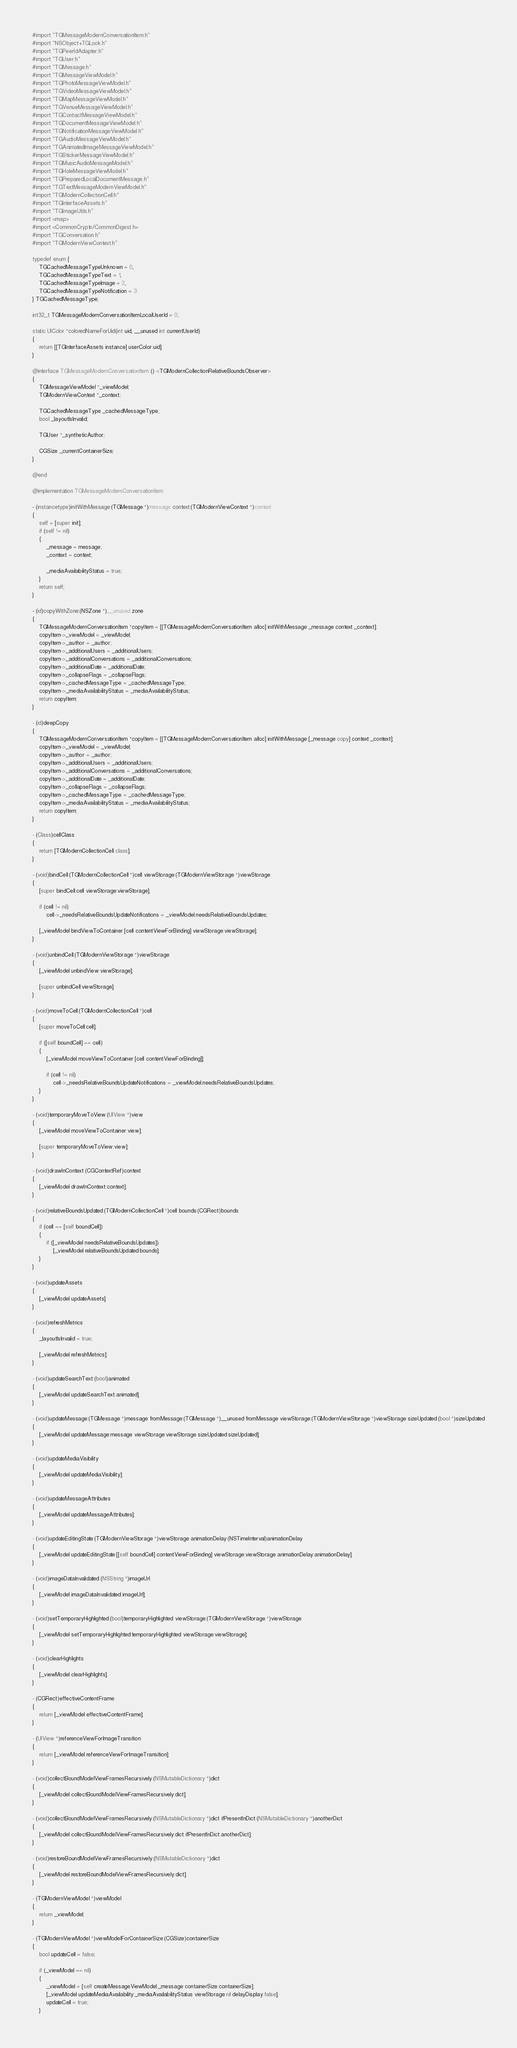Convert code to text. <code><loc_0><loc_0><loc_500><loc_500><_ObjectiveC_>#import "TGMessageModernConversationItem.h"
#import "NSObject+TGLock.h"
#import "TGPeerIdAdapter.h"
#import "TGUser.h"
#import "TGMessage.h"
#import "TGMessageViewModel.h"
#import "TGPhotoMessageViewModel.h"
#import "TGVideoMessageViewModel.h"
#import "TGMapMessageViewModel.h"
#import "TGVenueMessageViewModel.h"
#import "TGContactMessageViewModel.h"
#import "TGDocumentMessageViewModel.h"
#import "TGNotificationMessageViewModel.h"
#import "TGAudioMessageViewModel.h"
#import "TGAnimatedImageMessageViewModel.h"
#import "TGStickerMessageViewModel.h"
#import "TGMusicAudioMessageModel.h"
#import "TGHoleMessageViewModel.h"
#import "TGPreparedLocalDocumentMessage.h"
#import "TGTextMessageModernViewModel.h"
#import "TGModernCollectionCell.h"
#import "TGInterfaceAssets.h"
#import "TGImageUtils.h"
#import <map>
#import <CommonCrypto/CommonDigest.h>
#import "TGConversation.h"
#import "TGModernViewContext.h"

typedef enum {
    TGCachedMessageTypeUnknown = 0,
    TGCachedMessageTypeText = 1,
    TGCachedMessageTypeImage = 2,
    TGCachedMessageTypeNotification = 3
} TGCachedMessageType;

int32_t TGMessageModernConversationItemLocalUserId = 0;

static UIColor *coloredNameForUid(int uid, __unused int currentUserId)
{
    return [[TGInterfaceAssets instance] userColor:uid];
}

@interface TGMessageModernConversationItem () <TGModernCollectionRelativeBoundsObserver>
{
    TGMessageViewModel *_viewModel;
    TGModernViewContext *_context;
    
    TGCachedMessageType _cachedMessageType;
    bool _layoutIsInvalid;
    
    TGUser *_syntheticAuthor;
    
    CGSize _currentContainerSize;
}

@end

@implementation TGMessageModernConversationItem

- (instancetype)initWithMessage:(TGMessage *)message context:(TGModernViewContext *)context
{
    self = [super init];
    if (self != nil)
    {
        _message = message;
        _context = context;
        
        _mediaAvailabilityStatus = true;
    }
    return self;
}

- (id)copyWithZone:(NSZone *)__unused zone
{
    TGMessageModernConversationItem *copyItem = [[TGMessageModernConversationItem alloc] initWithMessage:_message context:_context];
    copyItem->_viewModel = _viewModel;
    copyItem->_author = _author;
    copyItem->_additionalUsers = _additionalUsers;
    copyItem->_additionalConversations = _additionalConversations;
    copyItem->_additionalDate = _additionalDate;
    copyItem->_collapseFlags = _collapseFlags;
    copyItem->_cachedMessageType = _cachedMessageType;
    copyItem->_mediaAvailabilityStatus = _mediaAvailabilityStatus;
    return copyItem;
}

- (id)deepCopy
{
    TGMessageModernConversationItem *copyItem = [[TGMessageModernConversationItem alloc] initWithMessage:[_message copy] context:_context];
    copyItem->_viewModel = _viewModel;
    copyItem->_author = _author;
    copyItem->_additionalUsers = _additionalUsers;
    copyItem->_additionalConversations = _additionalConversations;
    copyItem->_additionalDate = _additionalDate;
    copyItem->_collapseFlags = _collapseFlags;
    copyItem->_cachedMessageType = _cachedMessageType;
    copyItem->_mediaAvailabilityStatus = _mediaAvailabilityStatus;
    return copyItem;
}

- (Class)cellClass
{
    return [TGModernCollectionCell class];
}

- (void)bindCell:(TGModernCollectionCell *)cell viewStorage:(TGModernViewStorage *)viewStorage
{
    [super bindCell:cell viewStorage:viewStorage];
    
    if (cell != nil)
        cell->_needsRelativeBoundsUpdateNotifications = _viewModel.needsRelativeBoundsUpdates;
    
    [_viewModel bindViewToContainer:[cell contentViewForBinding] viewStorage:viewStorage];
}

- (void)unbindCell:(TGModernViewStorage *)viewStorage
{
    [_viewModel unbindView:viewStorage];
    
    [super unbindCell:viewStorage];
}

- (void)moveToCell:(TGModernCollectionCell *)cell
{
    [super moveToCell:cell];
    
    if ([self boundCell] == cell)
    {
        [_viewModel moveViewToContainer:[cell contentViewForBinding]];
        
        if (cell != nil)
            cell->_needsRelativeBoundsUpdateNotifications = _viewModel.needsRelativeBoundsUpdates;
    }
}

- (void)temporaryMoveToView:(UIView *)view
{
    [_viewModel moveViewToContainer:view];
    
    [super temporaryMoveToView:view];
}

- (void)drawInContext:(CGContextRef)context
{
    [_viewModel drawInContext:context];
}

- (void)relativeBoundsUpdated:(TGModernCollectionCell *)cell bounds:(CGRect)bounds
{
    if (cell == [self boundCell])
    {
        if ([_viewModel needsRelativeBoundsUpdates])
            [_viewModel relativeBoundsUpdated:bounds];
    }
}

- (void)updateAssets
{
    [_viewModel updateAssets];
}

- (void)refreshMetrics
{
    _layoutIsInvalid = true;
    
    [_viewModel refreshMetrics];
}

- (void)updateSearchText:(bool)animated
{
    [_viewModel updateSearchText:animated];
}

- (void)updateMessage:(TGMessage *)message fromMessage:(TGMessage *)__unused fromMessage viewStorage:(TGModernViewStorage *)viewStorage sizeUpdated:(bool *)sizeUpdated
{
    [_viewModel updateMessage:message viewStorage:viewStorage sizeUpdated:sizeUpdated];
}

- (void)updateMediaVisibility
{
    [_viewModel updateMediaVisibility];
}

- (void)updateMessageAttributes
{
    [_viewModel updateMessageAttributes];
}

- (void)updateEditingState:(TGModernViewStorage *)viewStorage animationDelay:(NSTimeInterval)animationDelay
{
    [_viewModel updateEditingState:[[self boundCell] contentViewForBinding] viewStorage:viewStorage animationDelay:animationDelay];
}

- (void)imageDataInvalidated:(NSString *)imageUrl
{
    [_viewModel imageDataInvalidated:imageUrl];
}

- (void)setTemporaryHighlighted:(bool)temporaryHighlighted viewStorage:(TGModernViewStorage *)viewStorage
{
    [_viewModel setTemporaryHighlighted:temporaryHighlighted viewStorage:viewStorage];
}

- (void)clearHighlights
{
    [_viewModel clearHighlights];
}

- (CGRect)effectiveContentFrame
{
    return [_viewModel effectiveContentFrame];
}

- (UIView *)referenceViewForImageTransition
{
    return [_viewModel referenceViewForImageTransition];
}

- (void)collectBoundModelViewFramesRecursively:(NSMutableDictionary *)dict
{
    [_viewModel collectBoundModelViewFramesRecursively:dict];
}

- (void)collectBoundModelViewFramesRecursively:(NSMutableDictionary *)dict ifPresentInDict:(NSMutableDictionary *)anotherDict
{
    [_viewModel collectBoundModelViewFramesRecursively:dict ifPresentInDict:anotherDict];
}

- (void)restoreBoundModelViewFramesRecursively:(NSMutableDictionary *)dict
{
    [_viewModel restoreBoundModelViewFramesRecursively:dict];
}

- (TGModernViewModel *)viewModel
{
    return _viewModel;
}

- (TGModernViewModel *)viewModelForContainerSize:(CGSize)containerSize
{
    bool updateCell = false;
    
    if (_viewModel == nil)
    {
        _viewModel = [self createMessageViewModel:_message containerSize:containerSize];
        [_viewModel updateMediaAvailability:_mediaAvailabilityStatus viewStorage:nil delayDisplay:false];
        updateCell = true;
    }</code> 